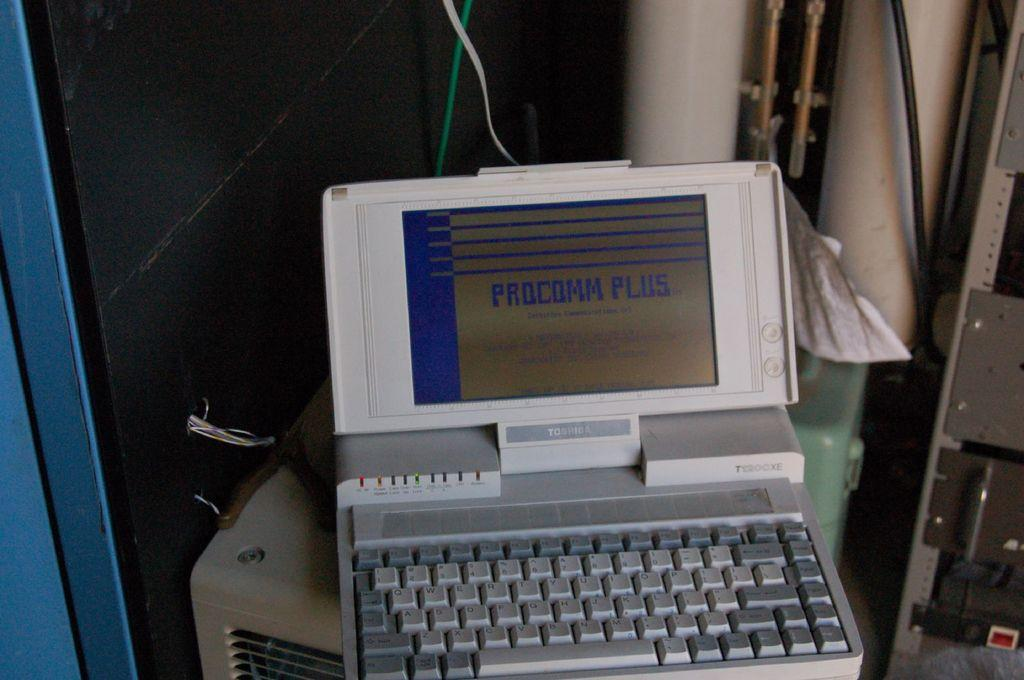<image>
Summarize the visual content of the image. Picture of a laptop that includes information on procomm plus 